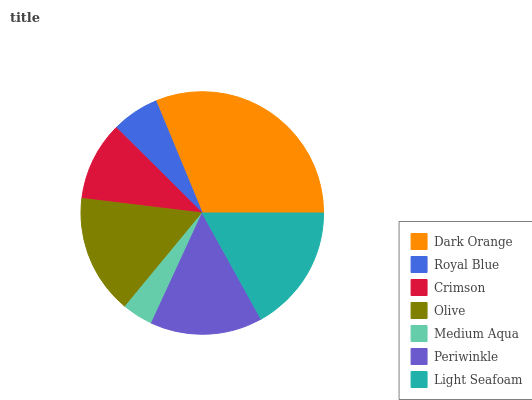Is Medium Aqua the minimum?
Answer yes or no. Yes. Is Dark Orange the maximum?
Answer yes or no. Yes. Is Royal Blue the minimum?
Answer yes or no. No. Is Royal Blue the maximum?
Answer yes or no. No. Is Dark Orange greater than Royal Blue?
Answer yes or no. Yes. Is Royal Blue less than Dark Orange?
Answer yes or no. Yes. Is Royal Blue greater than Dark Orange?
Answer yes or no. No. Is Dark Orange less than Royal Blue?
Answer yes or no. No. Is Periwinkle the high median?
Answer yes or no. Yes. Is Periwinkle the low median?
Answer yes or no. Yes. Is Dark Orange the high median?
Answer yes or no. No. Is Medium Aqua the low median?
Answer yes or no. No. 